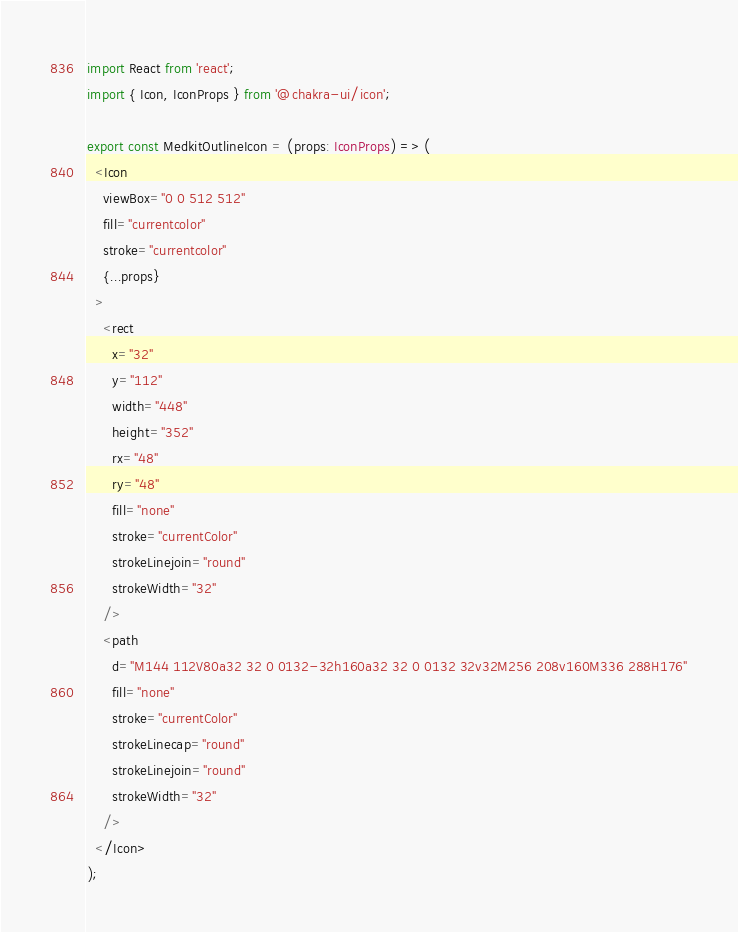<code> <loc_0><loc_0><loc_500><loc_500><_TypeScript_>import React from 'react';
import { Icon, IconProps } from '@chakra-ui/icon';

export const MedkitOutlineIcon = (props: IconProps) => (
  <Icon
    viewBox="0 0 512 512"
    fill="currentcolor"
    stroke="currentcolor"
    {...props}
  >
    <rect
      x="32"
      y="112"
      width="448"
      height="352"
      rx="48"
      ry="48"
      fill="none"
      stroke="currentColor"
      strokeLinejoin="round"
      strokeWidth="32"
    />
    <path
      d="M144 112V80a32 32 0 0132-32h160a32 32 0 0132 32v32M256 208v160M336 288H176"
      fill="none"
      stroke="currentColor"
      strokeLinecap="round"
      strokeLinejoin="round"
      strokeWidth="32"
    />
  </Icon>
);
</code> 